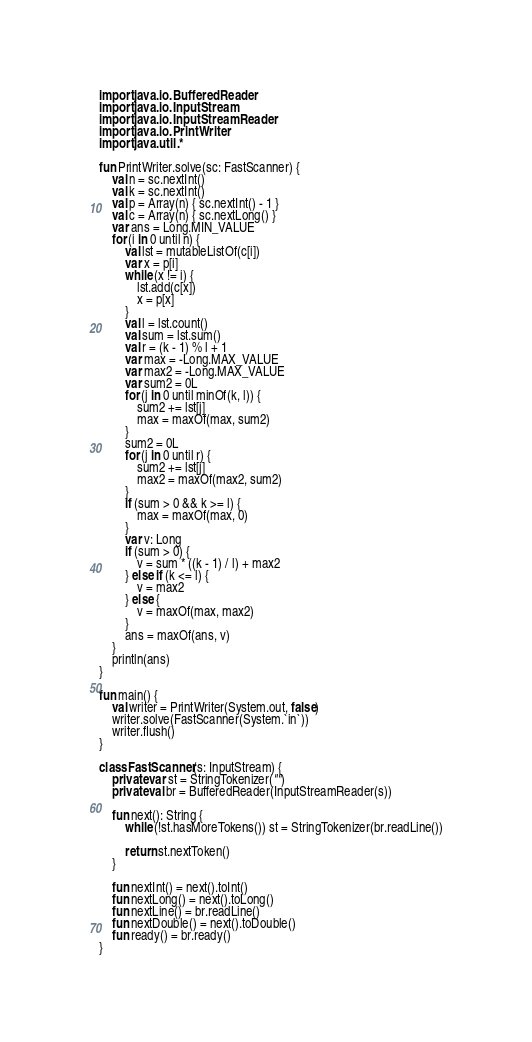<code> <loc_0><loc_0><loc_500><loc_500><_Kotlin_>import java.io.BufferedReader
import java.io.InputStream
import java.io.InputStreamReader
import java.io.PrintWriter
import java.util.*

fun PrintWriter.solve(sc: FastScanner) {
    val n = sc.nextInt()
    val k = sc.nextInt()
    val p = Array(n) { sc.nextInt() - 1 }
    val c = Array(n) { sc.nextLong() }
    var ans = Long.MIN_VALUE
    for (i in 0 until n) {
        val lst = mutableListOf(c[i])
        var x = p[i]
        while (x != i) {
            lst.add(c[x])
            x = p[x]
        }
        val l = lst.count()
        val sum = lst.sum()
        val r = (k - 1) % l + 1
        var max = -Long.MAX_VALUE
        var max2 = -Long.MAX_VALUE
        var sum2 = 0L
        for (j in 0 until minOf(k, l)) {
            sum2 += lst[j]
            max = maxOf(max, sum2)
        }
        sum2 = 0L
        for (j in 0 until r) {
            sum2 += lst[j]
            max2 = maxOf(max2, sum2)
        }
        if (sum > 0 && k >= l) {
            max = maxOf(max, 0)
        }
        var v: Long
        if (sum > 0) {
            v = sum * ((k - 1) / l) + max2
        } else if (k <= l) {
            v = max2
        } else {
            v = maxOf(max, max2)
        }
        ans = maxOf(ans, v)
    }
    println(ans)
}

fun main() {
    val writer = PrintWriter(System.out, false)
    writer.solve(FastScanner(System.`in`))
    writer.flush()
}

class FastScanner(s: InputStream) {
    private var st = StringTokenizer("")
    private val br = BufferedReader(InputStreamReader(s))

    fun next(): String {
        while (!st.hasMoreTokens()) st = StringTokenizer(br.readLine())

        return st.nextToken()
    }

    fun nextInt() = next().toInt()
    fun nextLong() = next().toLong()
    fun nextLine() = br.readLine()
    fun nextDouble() = next().toDouble()
    fun ready() = br.ready()
}
</code> 